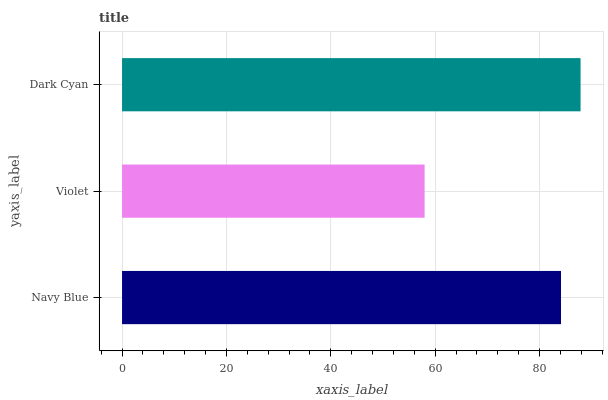Is Violet the minimum?
Answer yes or no. Yes. Is Dark Cyan the maximum?
Answer yes or no. Yes. Is Dark Cyan the minimum?
Answer yes or no. No. Is Violet the maximum?
Answer yes or no. No. Is Dark Cyan greater than Violet?
Answer yes or no. Yes. Is Violet less than Dark Cyan?
Answer yes or no. Yes. Is Violet greater than Dark Cyan?
Answer yes or no. No. Is Dark Cyan less than Violet?
Answer yes or no. No. Is Navy Blue the high median?
Answer yes or no. Yes. Is Navy Blue the low median?
Answer yes or no. Yes. Is Dark Cyan the high median?
Answer yes or no. No. Is Dark Cyan the low median?
Answer yes or no. No. 